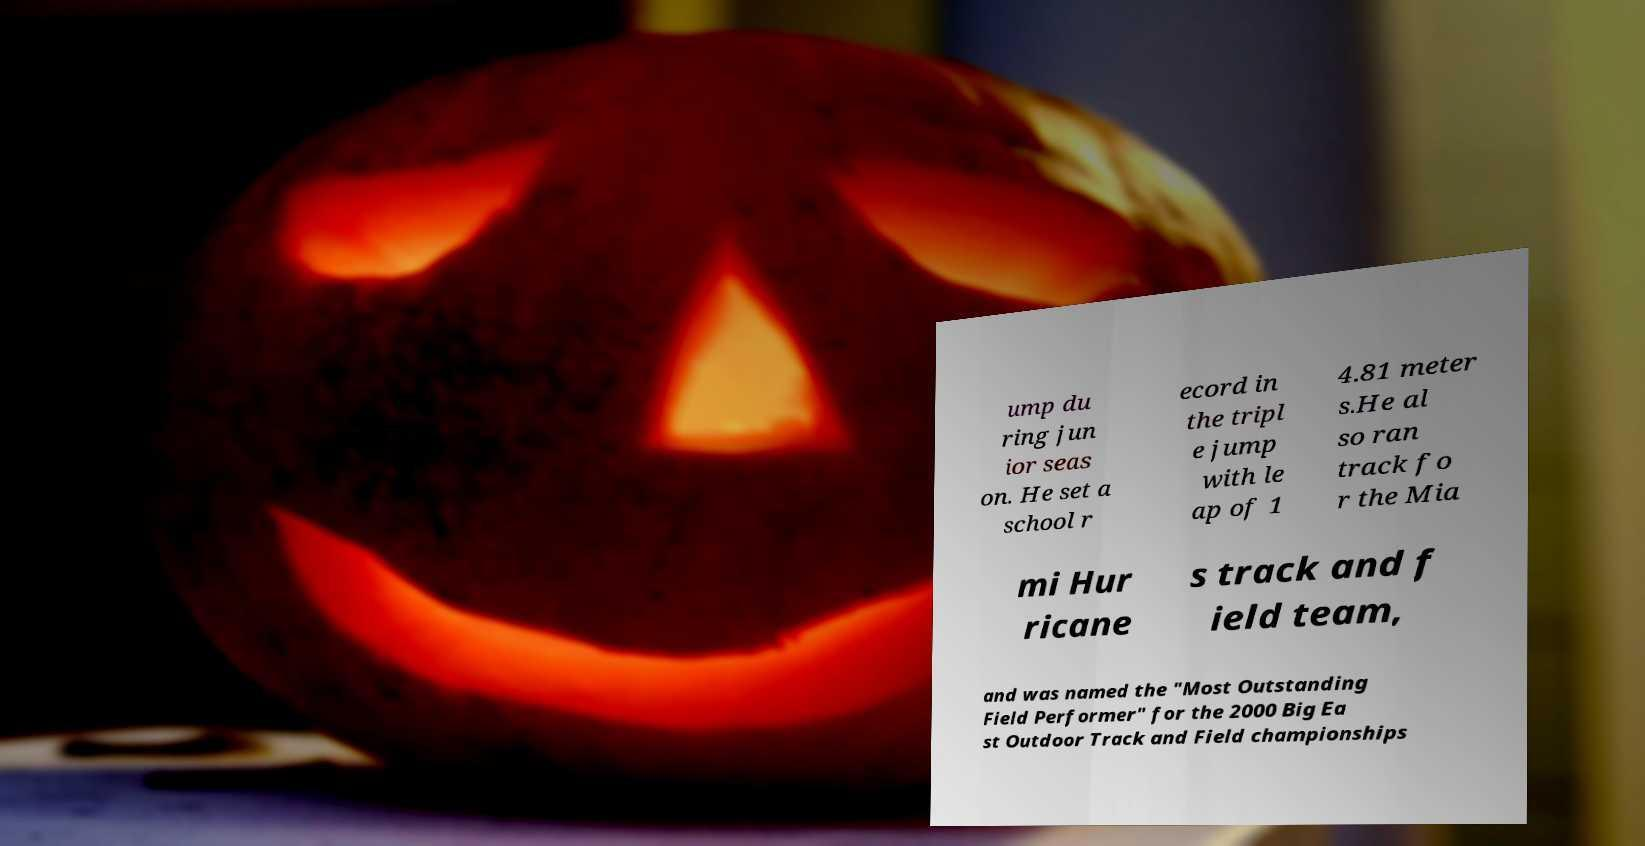I need the written content from this picture converted into text. Can you do that? ump du ring jun ior seas on. He set a school r ecord in the tripl e jump with le ap of 1 4.81 meter s.He al so ran track fo r the Mia mi Hur ricane s track and f ield team, and was named the "Most Outstanding Field Performer" for the 2000 Big Ea st Outdoor Track and Field championships 